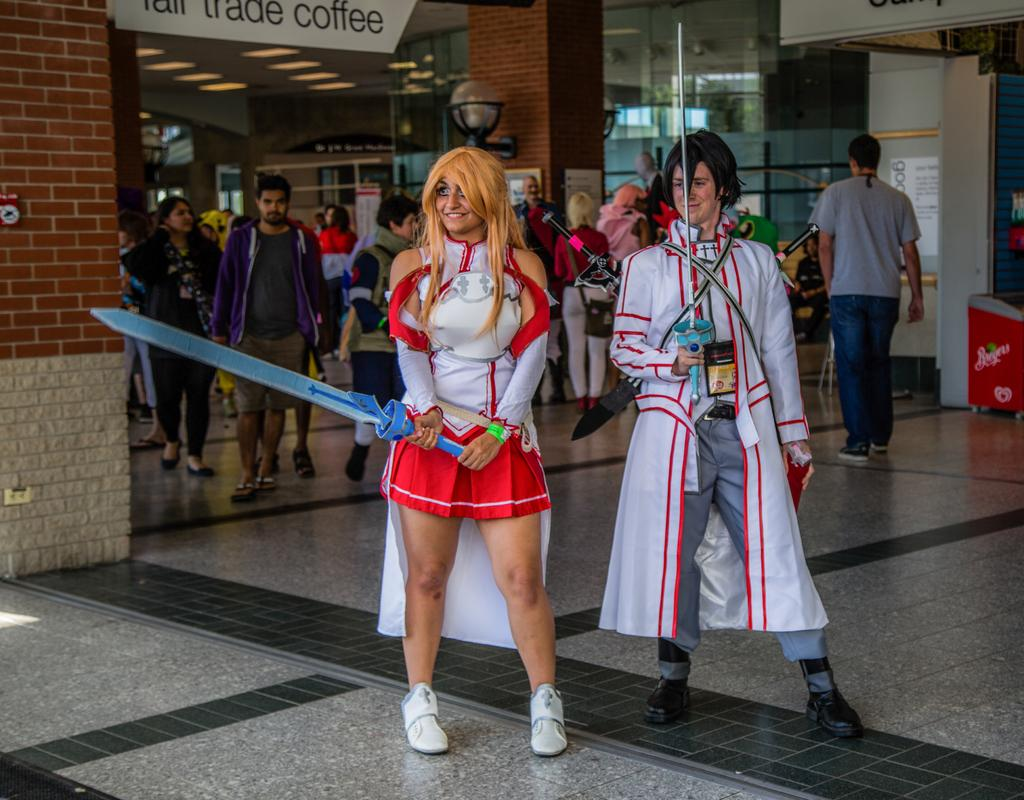<image>
Describe the image concisely. Two cosplay players are standing in front of a coffee shop. 